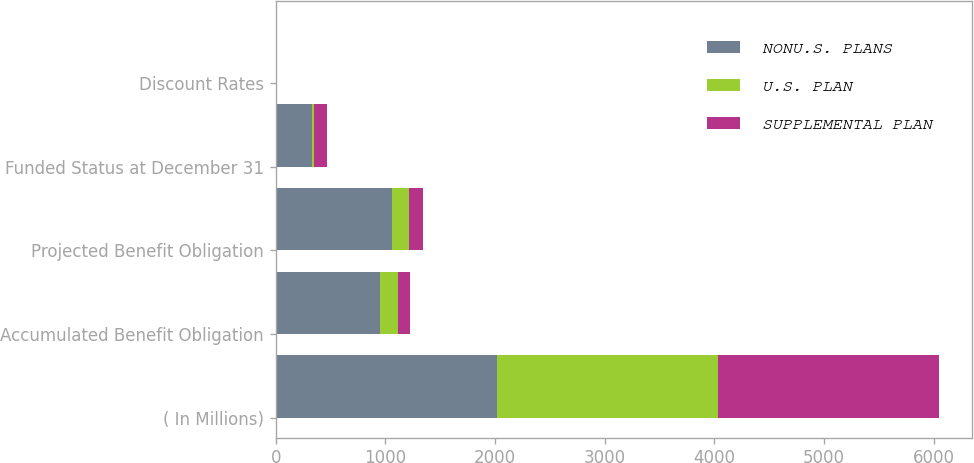<chart> <loc_0><loc_0><loc_500><loc_500><stacked_bar_chart><ecel><fcel>( In Millions)<fcel>Accumulated Benefit Obligation<fcel>Projected Benefit Obligation<fcel>Funded Status at December 31<fcel>Discount Rates<nl><fcel>NONU.S. PLANS<fcel>2016<fcel>953.2<fcel>1062.7<fcel>330.8<fcel>4.46<nl><fcel>U.S. PLAN<fcel>2016<fcel>158.3<fcel>155.9<fcel>16.6<fcel>2.39<nl><fcel>SUPPLEMENTAL PLAN<fcel>2016<fcel>108.9<fcel>121.1<fcel>121.1<fcel>4.46<nl></chart> 